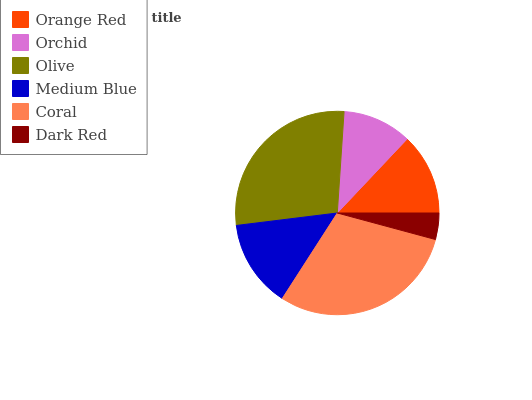Is Dark Red the minimum?
Answer yes or no. Yes. Is Coral the maximum?
Answer yes or no. Yes. Is Orchid the minimum?
Answer yes or no. No. Is Orchid the maximum?
Answer yes or no. No. Is Orange Red greater than Orchid?
Answer yes or no. Yes. Is Orchid less than Orange Red?
Answer yes or no. Yes. Is Orchid greater than Orange Red?
Answer yes or no. No. Is Orange Red less than Orchid?
Answer yes or no. No. Is Medium Blue the high median?
Answer yes or no. Yes. Is Orange Red the low median?
Answer yes or no. Yes. Is Orange Red the high median?
Answer yes or no. No. Is Medium Blue the low median?
Answer yes or no. No. 